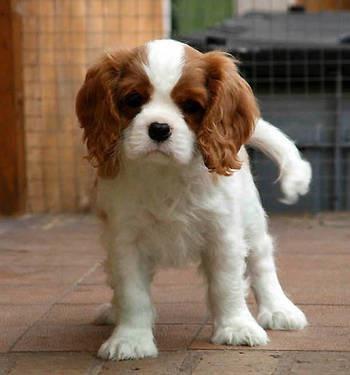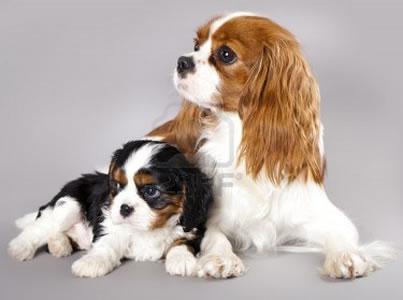The first image is the image on the left, the second image is the image on the right. For the images shown, is this caption "A rabbit is with at least one puppy." true? Answer yes or no. No. 